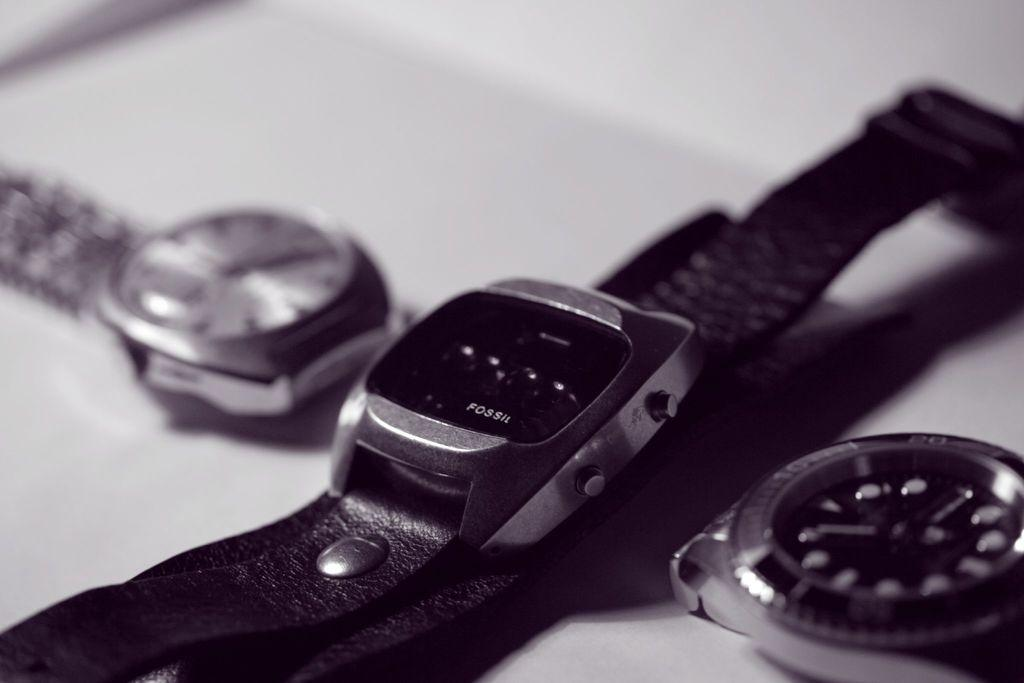How many wrist watches are visible in the image? There are three wrist watches in the image. Where are the wrist watches located? The wrist watches are placed on a surface. What type of hair is visible on the wrist watches in the image? There is no hair visible on the wrist watches in the image. 